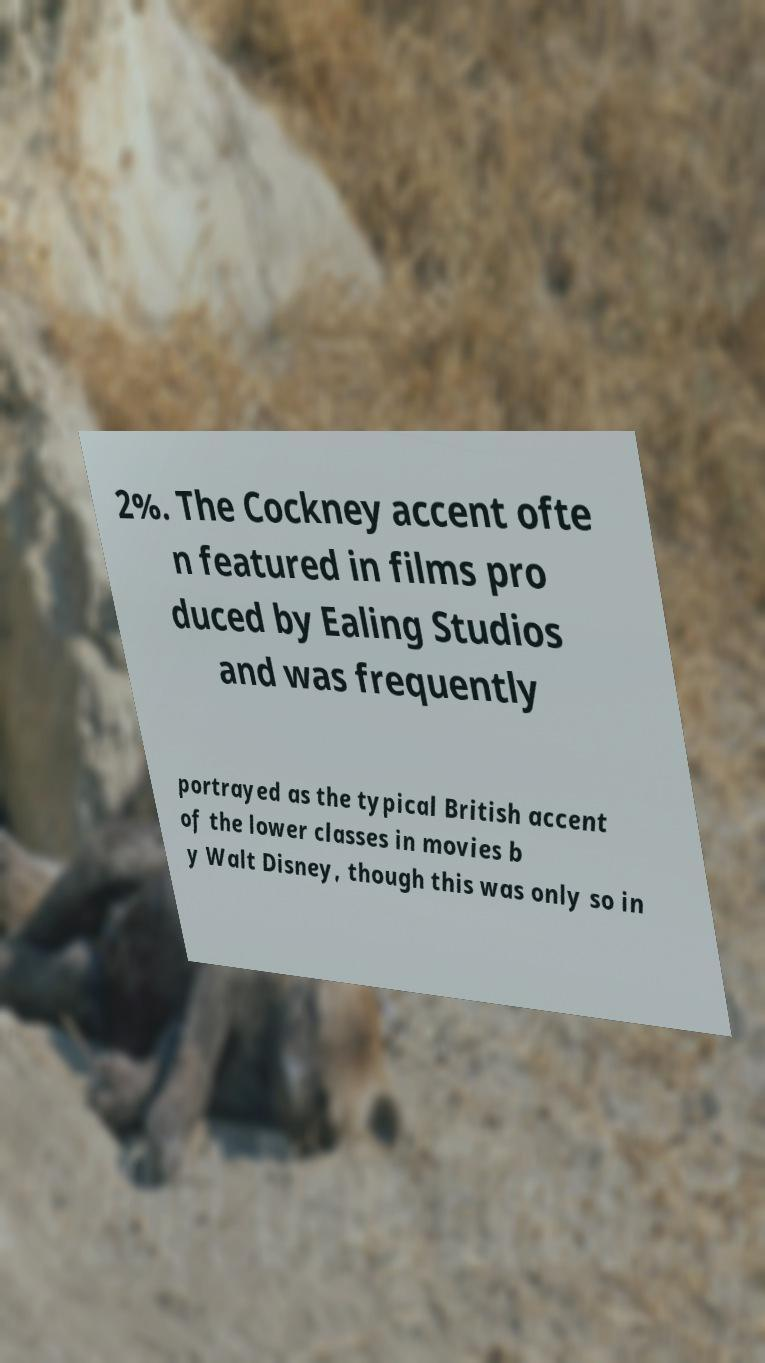Could you assist in decoding the text presented in this image and type it out clearly? 2%. The Cockney accent ofte n featured in films pro duced by Ealing Studios and was frequently portrayed as the typical British accent of the lower classes in movies b y Walt Disney, though this was only so in 